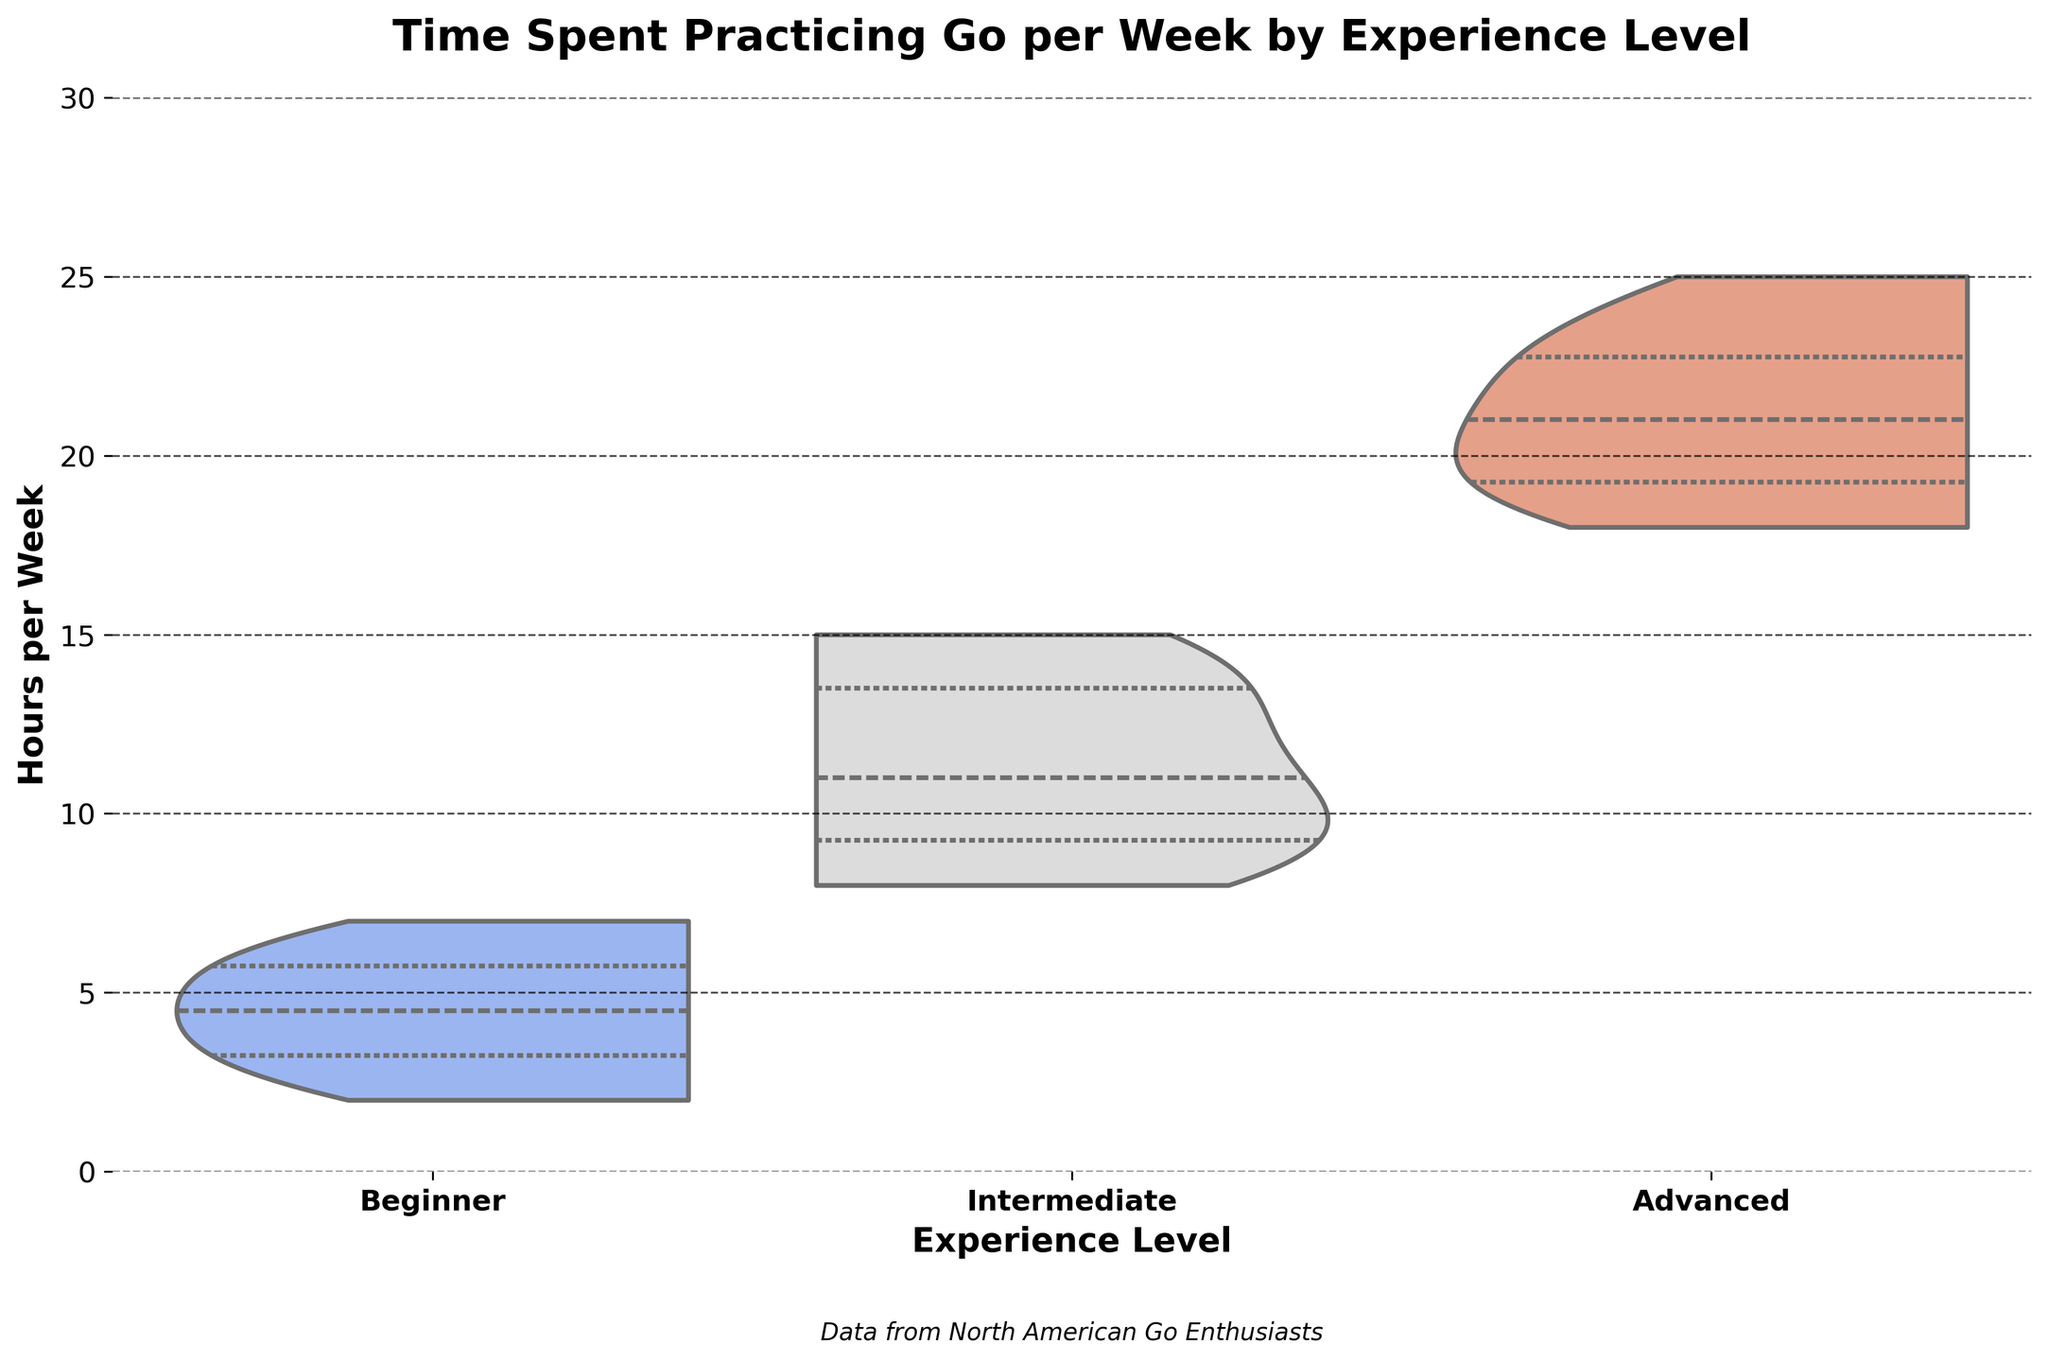What is the title of the figure? The title of the figure is displayed at the top in a bold font. It reads "Time Spent Practicing Go per Week by Experience Level."
Answer: Time Spent Practicing Go per Week by Experience Level What are the three experience levels represented on the x-axis? The x-axis shows three experience levels, which are Beginner, Intermediate, and Advanced. These categories are labeled clearly below the violins.
Answer: Beginner, Intermediate, Advanced What is the range of time spent practicing for Beginner players? By looking at the shape and spread of the violin plot for Beginners, we see that the range is from 2 to 7 hours per week, as the violin spans these values vertically.
Answer: 2 to 7 hours What is the median time spent practicing for Intermediate players? In the violin plot for Intermediate players, a white dot represents the median value. It is positioned at around 10 hours per week.
Answer: Around 10 hours Which experience level has the largest spread of time spent practicing? By comparing the width of each violin plot, Advanced players have the largest spread, ranging approximately from 18 to 25 hours per week. The other levels have narrower spreads.
Answer: Advanced What is the number of quartiles shown in each violin plot? Each violin plot includes inner lines indicating the quartiles. There are three quartiles shown: the first quartile, median (second quartile), and third quartile.
Answer: 3 quartiles Which experience level practices the least on average? By comparing the central tendencies of each violin plot, Beginners practice the least on average as their median value is the lowest among the three levels.
Answer: Beginner What is the maximum time spent practicing by any player? The maximum value is the highest point reached by any of the violins. For Advanced players, this point is at 25 hours per week.
Answer: 25 hours Are there any overlapping time ranges between different experience levels? Yes, there is an overlap between Beginners and Intermediate players in the range of 5 to 7 hours, but Intermediate and Advanced players do not overlap in their respective ranges.
Answer: Yes, between Beginners and Intermediate What additional information is provided at the bottom of the figure? A text at the bottom of the figure mentions, "Data from North American Go Enthusiasts," indicating the source of the data.
Answer: Data from North American Go Enthusiasts 